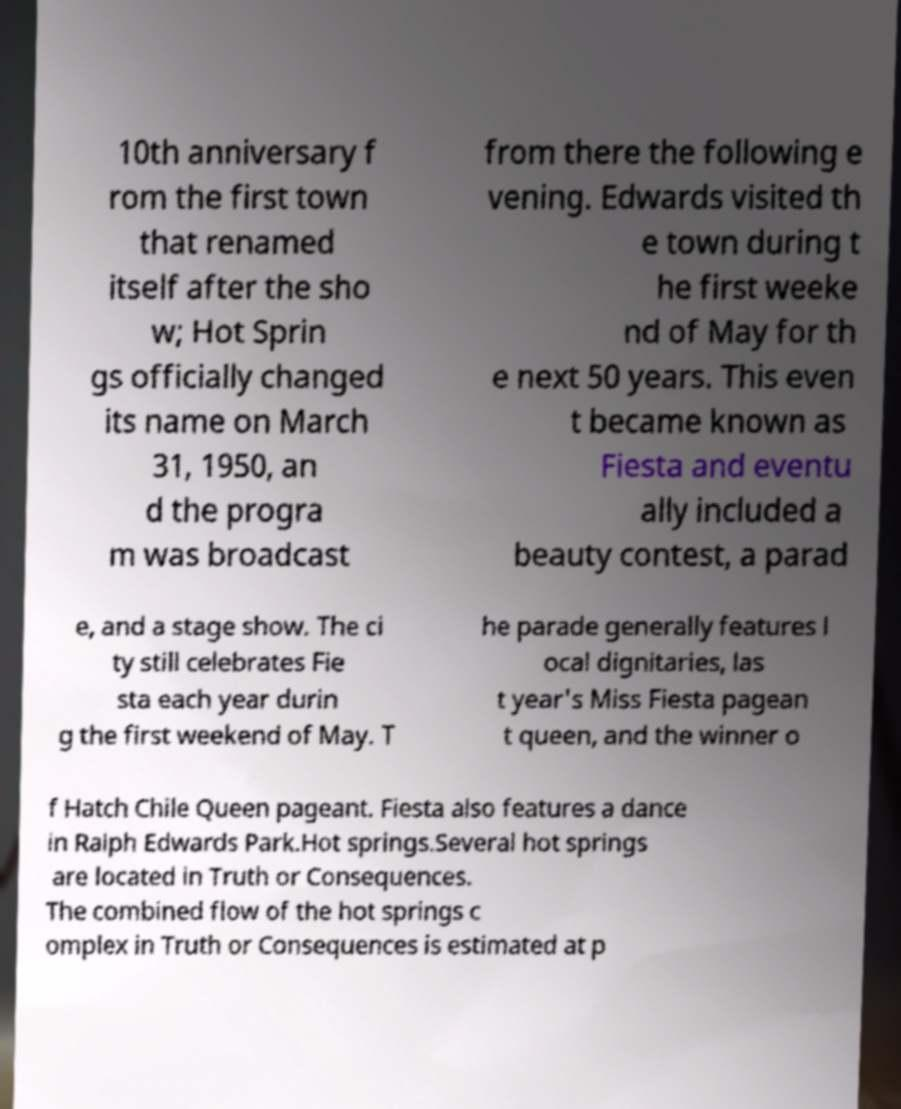For documentation purposes, I need the text within this image transcribed. Could you provide that? 10th anniversary f rom the first town that renamed itself after the sho w; Hot Sprin gs officially changed its name on March 31, 1950, an d the progra m was broadcast from there the following e vening. Edwards visited th e town during t he first weeke nd of May for th e next 50 years. This even t became known as Fiesta and eventu ally included a beauty contest, a parad e, and a stage show. The ci ty still celebrates Fie sta each year durin g the first weekend of May. T he parade generally features l ocal dignitaries, las t year's Miss Fiesta pagean t queen, and the winner o f Hatch Chile Queen pageant. Fiesta also features a dance in Ralph Edwards Park.Hot springs.Several hot springs are located in Truth or Consequences. The combined flow of the hot springs c omplex in Truth or Consequences is estimated at p 